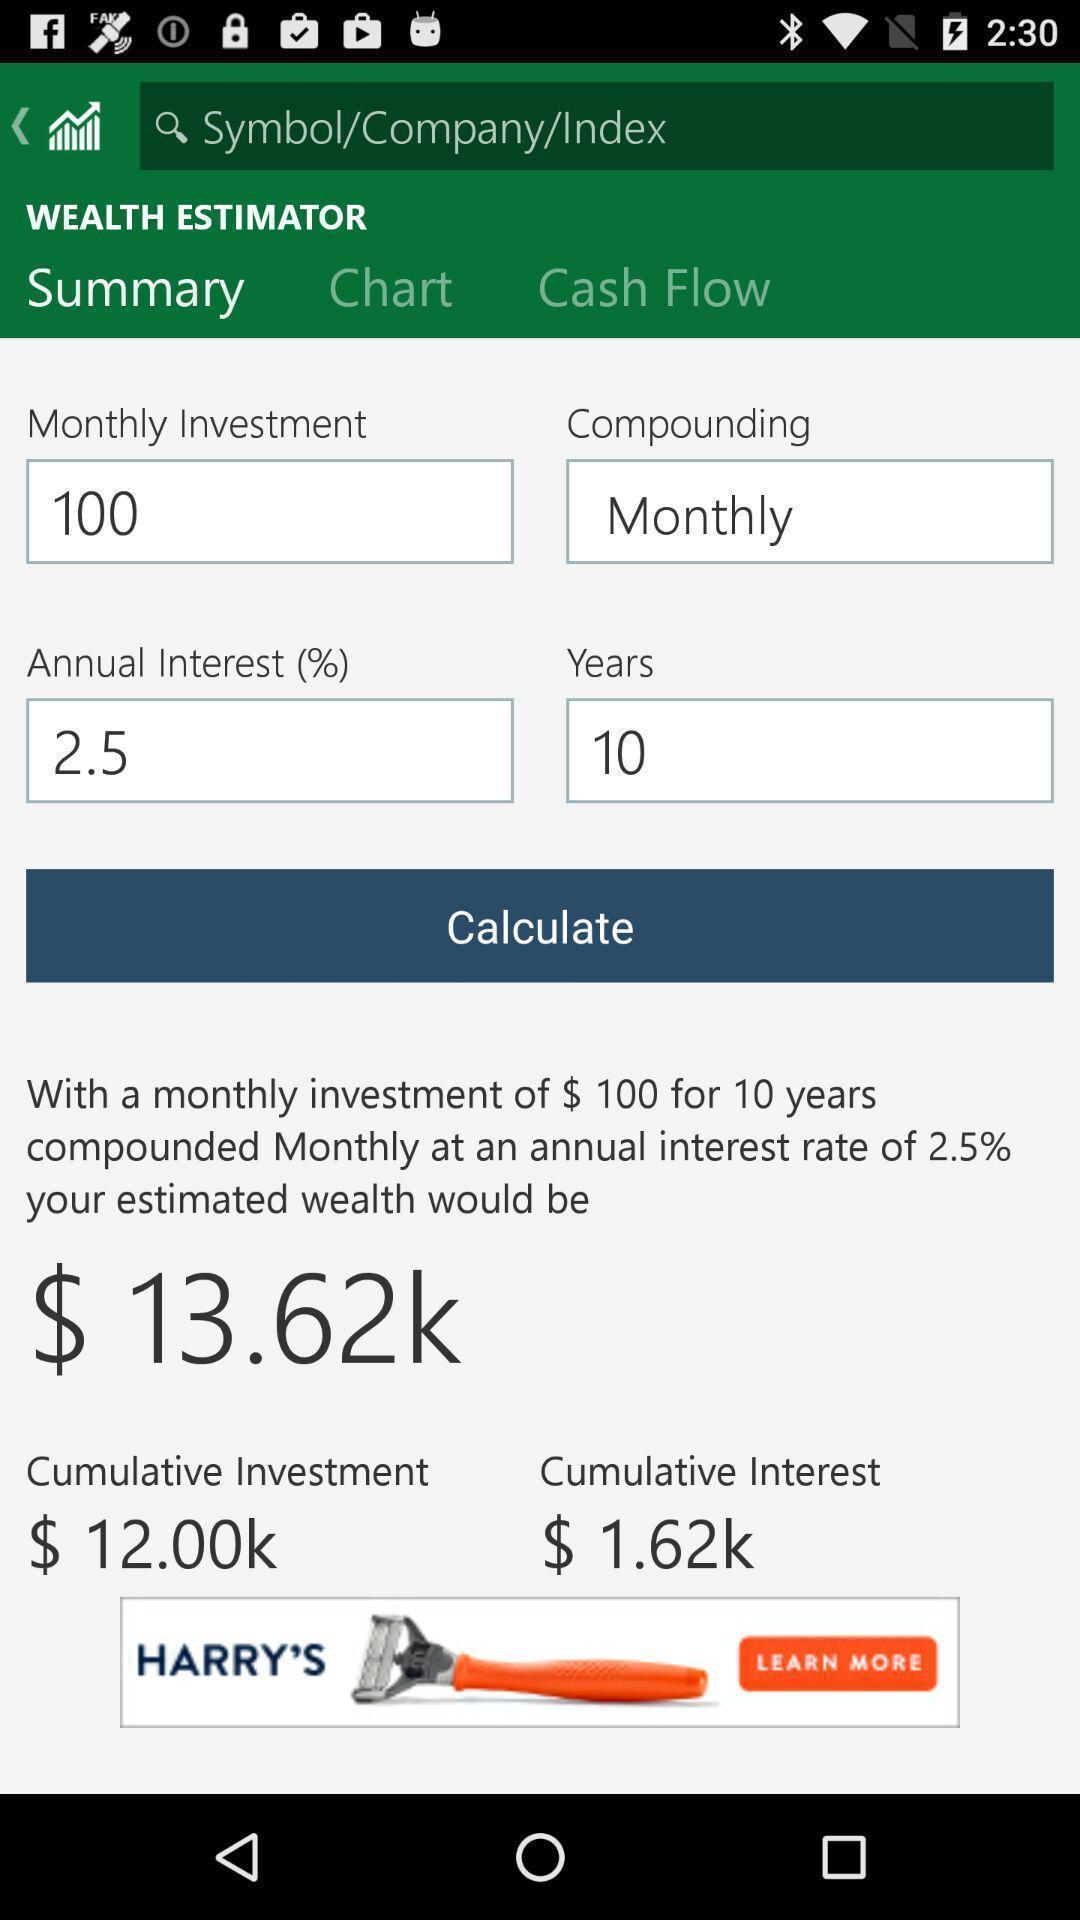What details can you identify in this image? Summary page showing some values in finance app. 